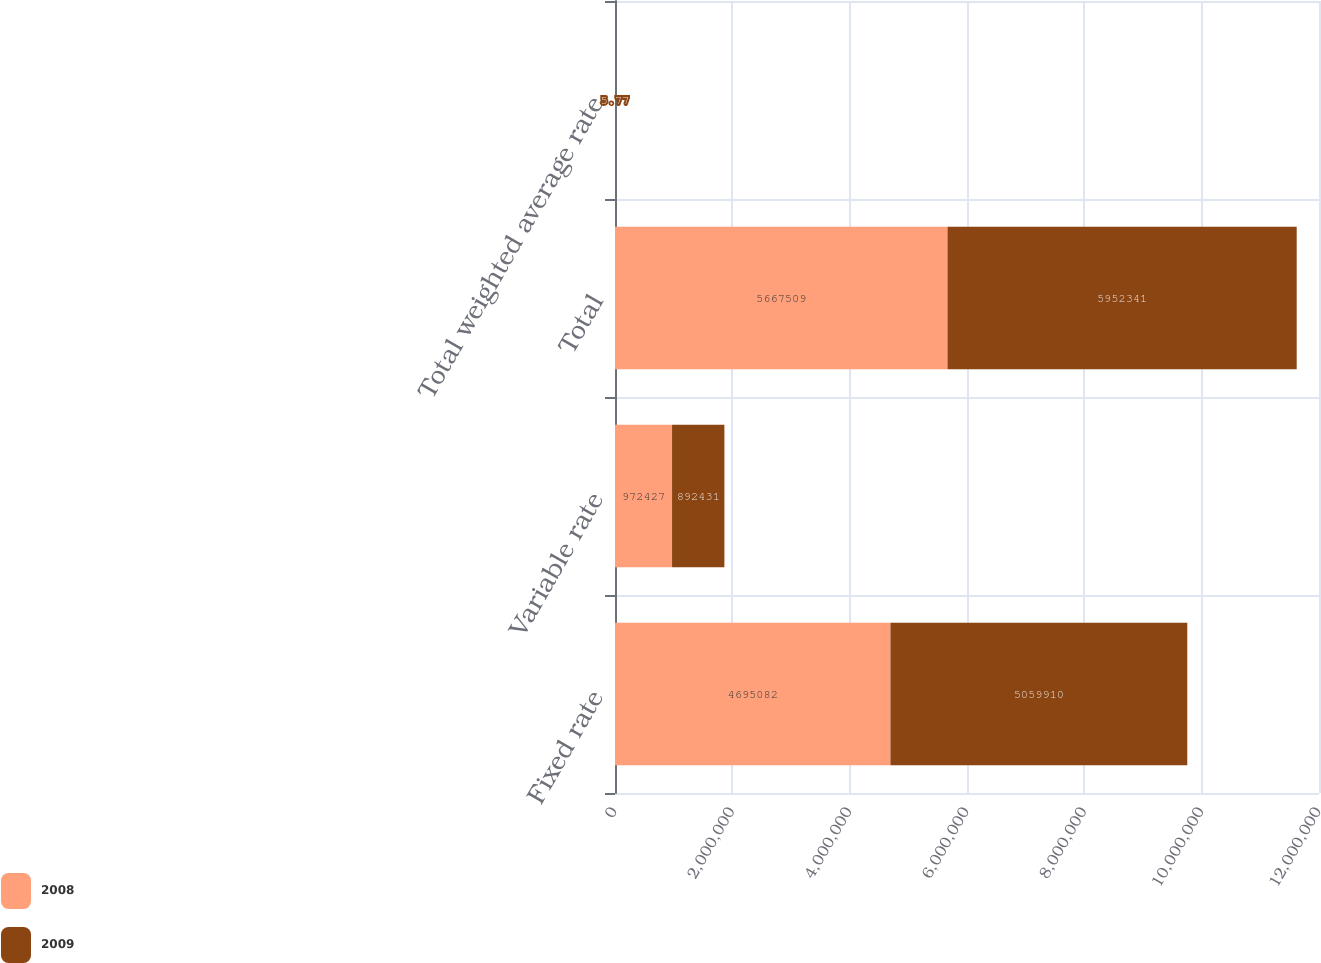<chart> <loc_0><loc_0><loc_500><loc_500><stacked_bar_chart><ecel><fcel>Fixed rate<fcel>Variable rate<fcel>Total<fcel>Total weighted average rate<nl><fcel>2008<fcel>4.69508e+06<fcel>972427<fcel>5.66751e+06<fcel>5.65<nl><fcel>2009<fcel>5.05991e+06<fcel>892431<fcel>5.95234e+06<fcel>5.77<nl></chart> 